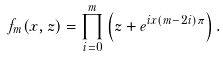<formula> <loc_0><loc_0><loc_500><loc_500>f _ { m } ( x , z ) = \prod _ { i = 0 } ^ { m } \left ( z + e ^ { i x ( m - 2 i ) \pi } \right ) .</formula> 